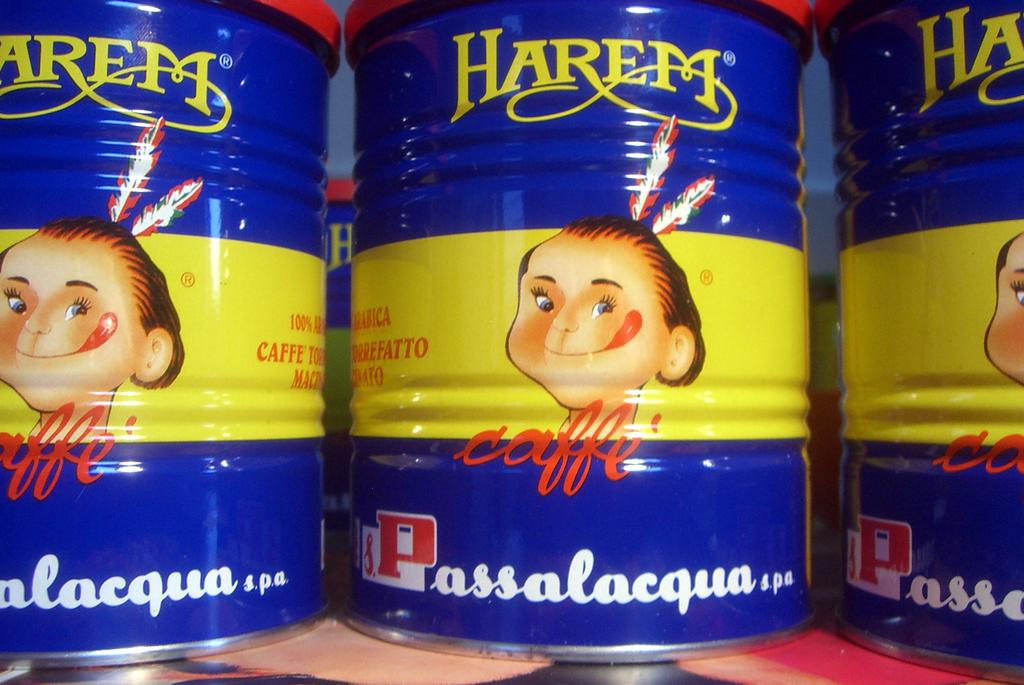<image>
Summarize the visual content of the image. Three tins of Harem Coffee featuring a blue and yellow label with an American Indian on the front. 